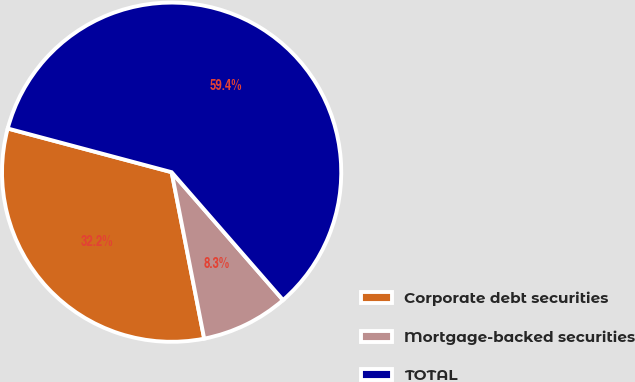<chart> <loc_0><loc_0><loc_500><loc_500><pie_chart><fcel>Corporate debt securities<fcel>Mortgage-backed securities<fcel>TOTAL<nl><fcel>32.22%<fcel>8.33%<fcel>59.44%<nl></chart> 